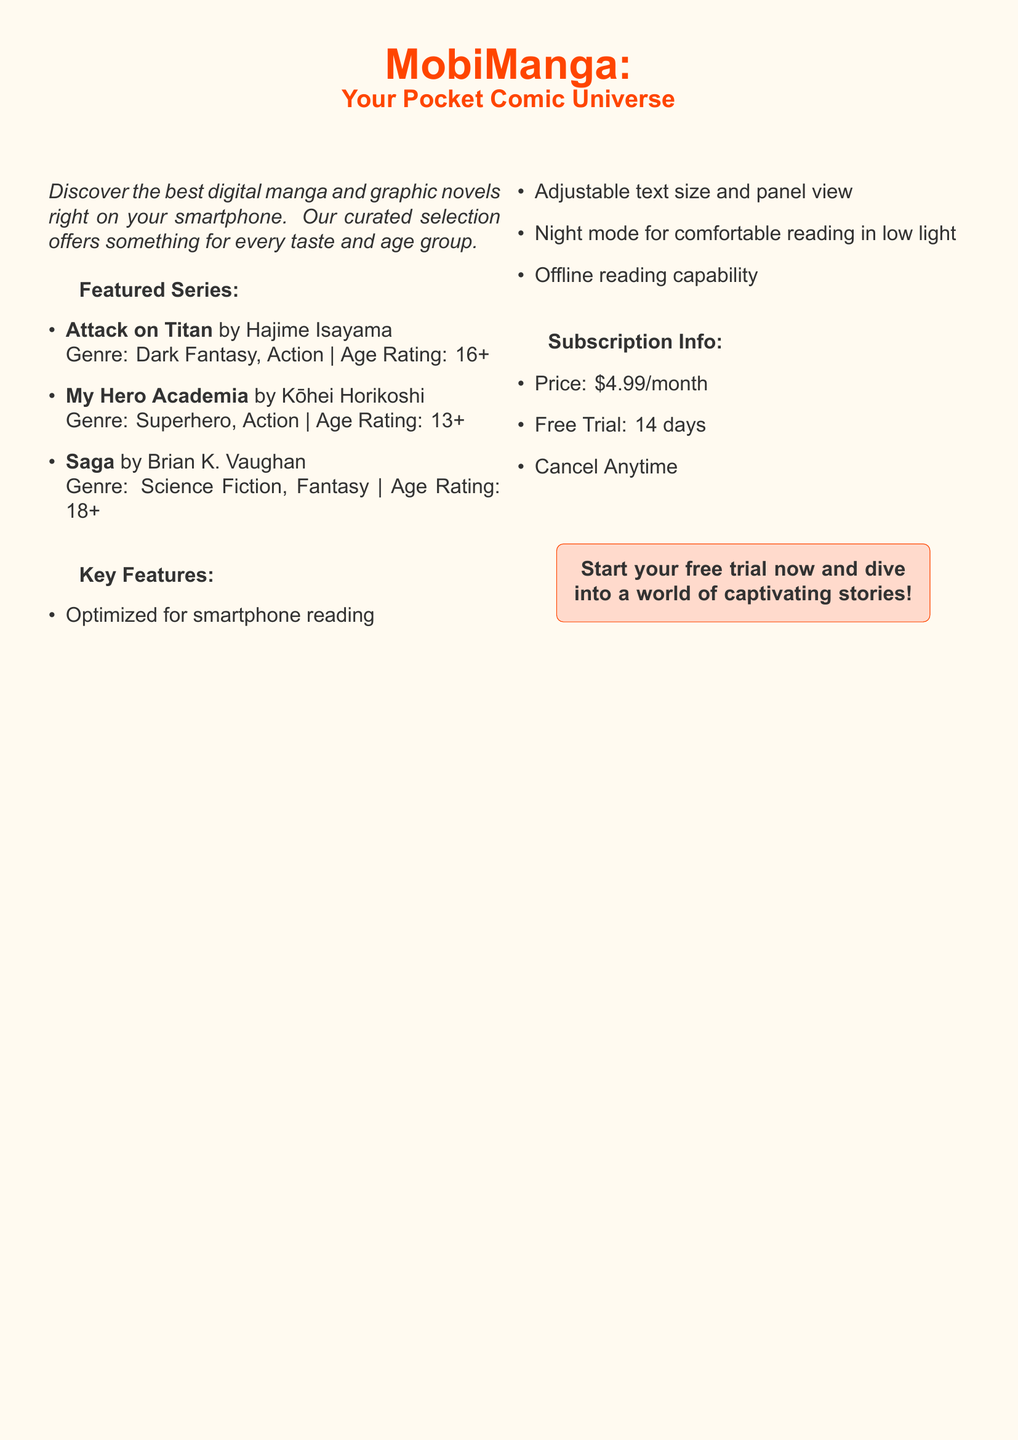What is the name of the first featured series? The first featured series in the document is listed as "Attack on Titan."
Answer: Attack on Titan What is the age rating for "My Hero Academia"? The document states the age rating for "My Hero Academia" as 13.
Answer: 13+ What genre does "Saga" belong to? The genre for "Saga" mentioned in the document includes science fiction and fantasy.
Answer: Science Fiction, Fantasy How much does the subscription cost per month? The monthly subscription price indicated in the document is $4.99.
Answer: $4.99 What is the duration of the free trial? The document specifies the free trial duration as 14 days.
Answer: 14 days Which series has the highest age rating? By comparing the age ratings in the document, "Saga" has the highest age rating of 18+.
Answer: 18+ What features are optimized for smartphone reading? The document lists features such as adjustable text size and panel view as important optimizations for smartphone reading.
Answer: Adjustable text size and panel view Is there an offline reading capability? The document mentions offline reading capability as one of the key features offered.
Answer: Yes What should users do to start their free trial? The document encourages users to "start your free trial now."
Answer: Start your free trial now 